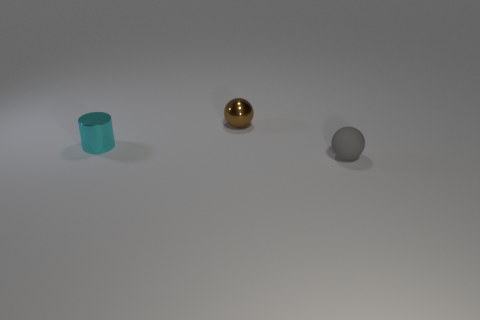Add 3 tiny brown spheres. How many objects exist? 6 Subtract all cylinders. How many objects are left? 2 Add 1 small cyan metal things. How many small cyan metal things are left? 2 Add 1 gray rubber objects. How many gray rubber objects exist? 2 Subtract 1 brown balls. How many objects are left? 2 Subtract all tiny metal cylinders. Subtract all cyan metallic things. How many objects are left? 1 